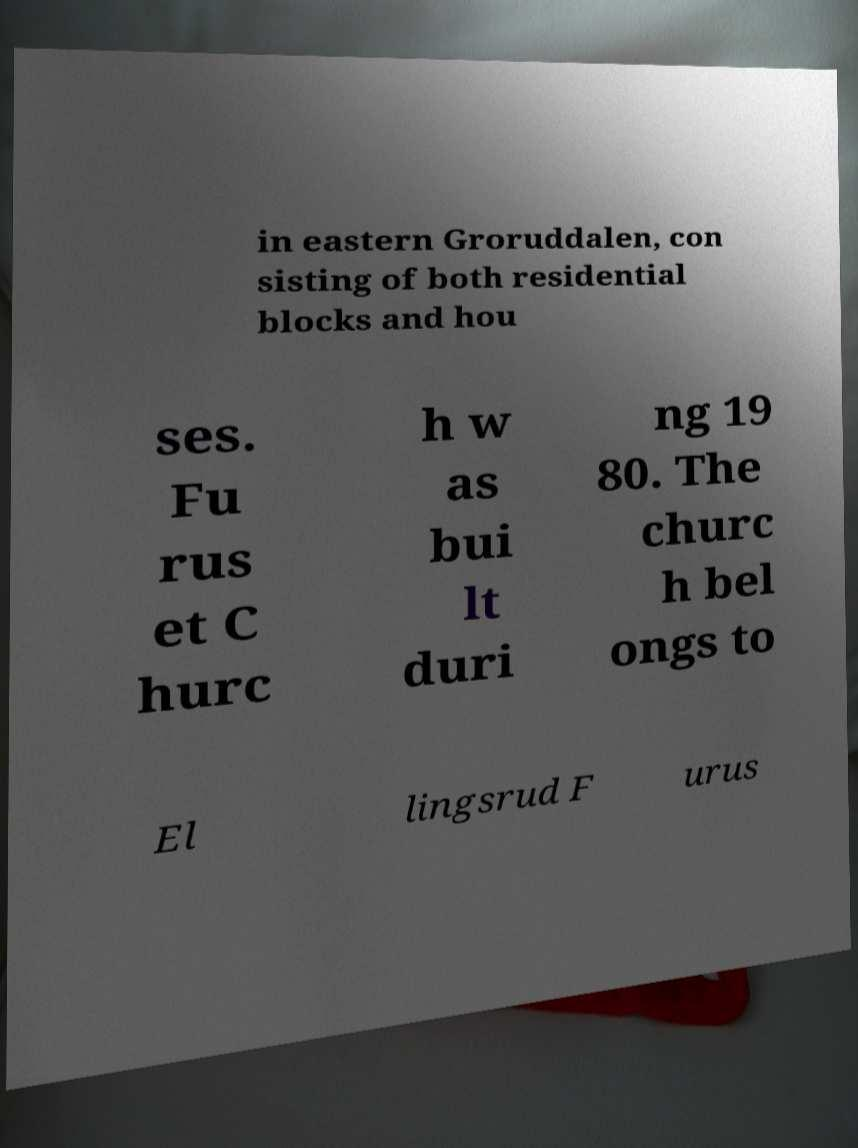Can you accurately transcribe the text from the provided image for me? in eastern Groruddalen, con sisting of both residential blocks and hou ses. Fu rus et C hurc h w as bui lt duri ng 19 80. The churc h bel ongs to El lingsrud F urus 